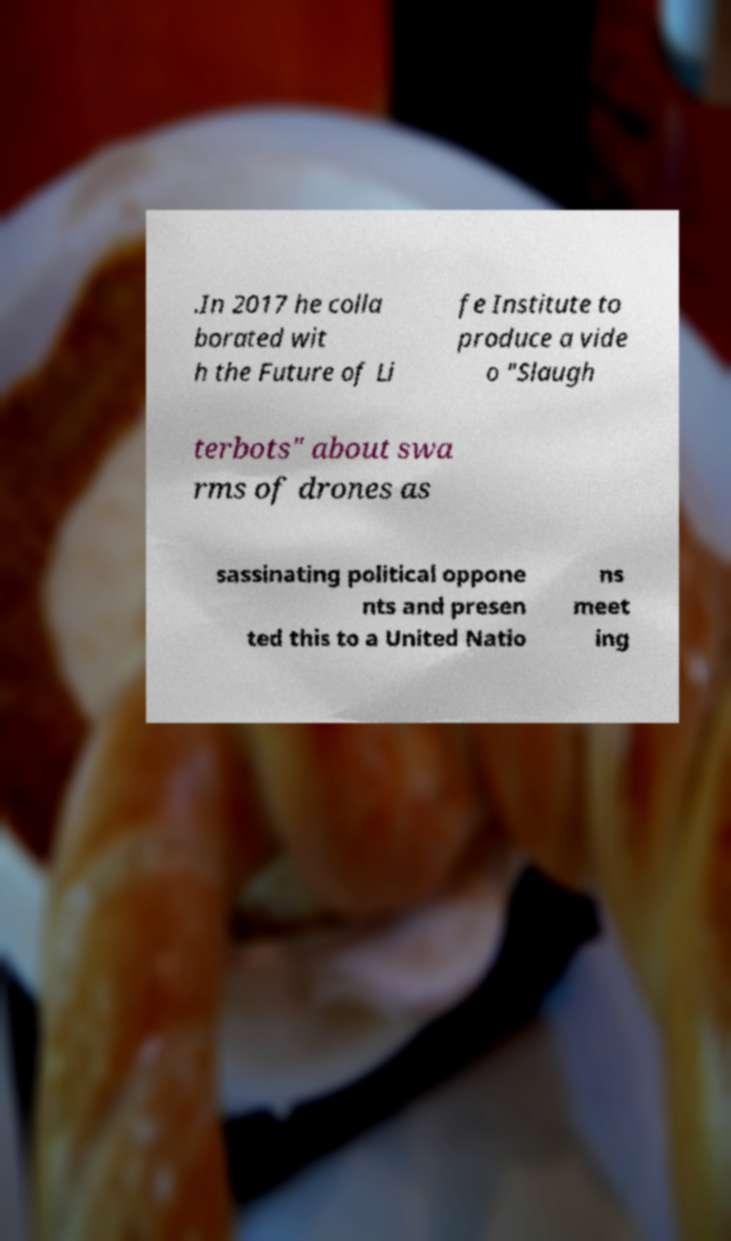Can you accurately transcribe the text from the provided image for me? .In 2017 he colla borated wit h the Future of Li fe Institute to produce a vide o "Slaugh terbots" about swa rms of drones as sassinating political oppone nts and presen ted this to a United Natio ns meet ing 